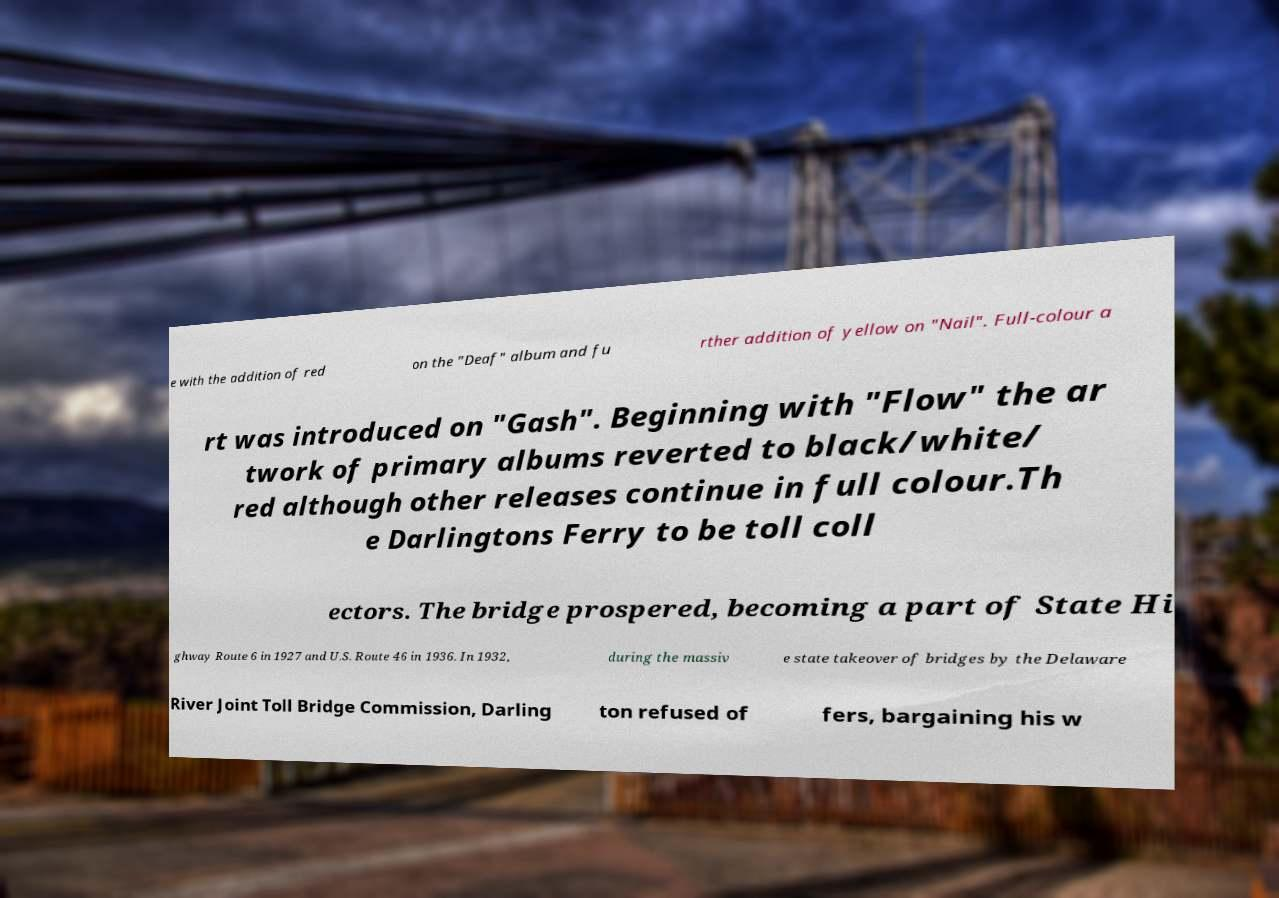For documentation purposes, I need the text within this image transcribed. Could you provide that? e with the addition of red on the "Deaf" album and fu rther addition of yellow on "Nail". Full-colour a rt was introduced on "Gash". Beginning with "Flow" the ar twork of primary albums reverted to black/white/ red although other releases continue in full colour.Th e Darlingtons Ferry to be toll coll ectors. The bridge prospered, becoming a part of State Hi ghway Route 6 in 1927 and U.S. Route 46 in 1936. In 1932, during the massiv e state takeover of bridges by the Delaware River Joint Toll Bridge Commission, Darling ton refused of fers, bargaining his w 